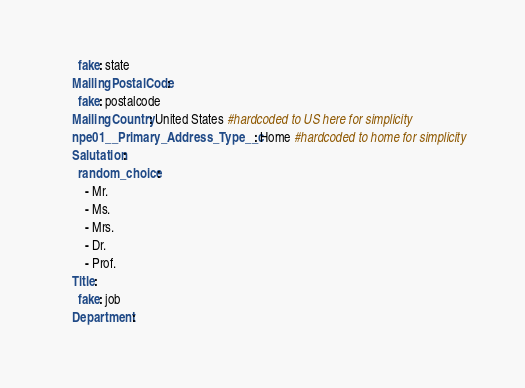<code> <loc_0><loc_0><loc_500><loc_500><_YAML_>      fake: state
    MailingPostalCode:
      fake: postalcode
    MailingCountry: United States #hardcoded to US here for simplicity
    npe01__Primary_Address_Type__c: Home #hardcoded to home for simplicity
    Salutation:
      random_choice:
        - Mr.
        - Ms.
        - Mrs.
        - Dr.
        - Prof. 
    Title:
      fake: job
    Department:</code> 